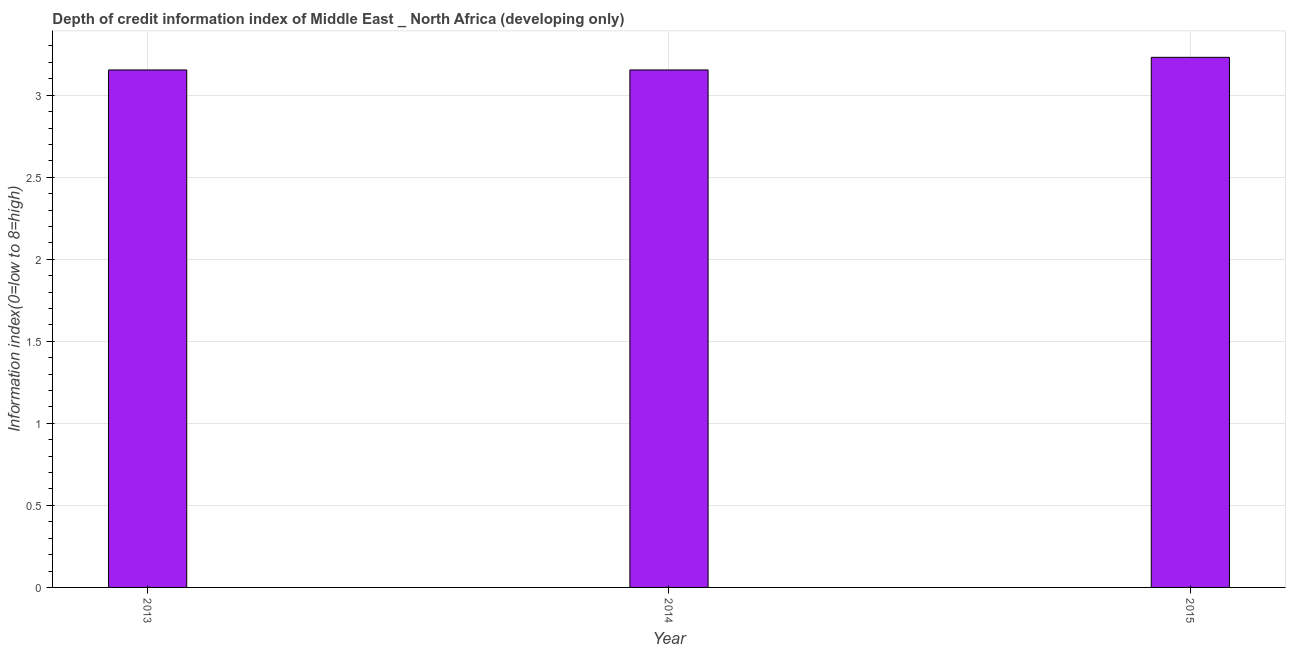Does the graph contain any zero values?
Your answer should be very brief. No. What is the title of the graph?
Provide a short and direct response. Depth of credit information index of Middle East _ North Africa (developing only). What is the label or title of the Y-axis?
Offer a very short reply. Information index(0=low to 8=high). What is the depth of credit information index in 2014?
Offer a terse response. 3.15. Across all years, what is the maximum depth of credit information index?
Make the answer very short. 3.23. Across all years, what is the minimum depth of credit information index?
Offer a very short reply. 3.15. In which year was the depth of credit information index maximum?
Ensure brevity in your answer.  2015. What is the sum of the depth of credit information index?
Provide a succinct answer. 9.54. What is the difference between the depth of credit information index in 2014 and 2015?
Provide a short and direct response. -0.08. What is the average depth of credit information index per year?
Your answer should be very brief. 3.18. What is the median depth of credit information index?
Your answer should be very brief. 3.15. What is the ratio of the depth of credit information index in 2014 to that in 2015?
Your answer should be very brief. 0.98. Is the depth of credit information index in 2013 less than that in 2014?
Your answer should be compact. No. Is the difference between the depth of credit information index in 2013 and 2014 greater than the difference between any two years?
Make the answer very short. No. What is the difference between the highest and the second highest depth of credit information index?
Offer a very short reply. 0.08. What is the difference between the highest and the lowest depth of credit information index?
Give a very brief answer. 0.08. In how many years, is the depth of credit information index greater than the average depth of credit information index taken over all years?
Offer a very short reply. 1. Are all the bars in the graph horizontal?
Your answer should be compact. No. How many years are there in the graph?
Keep it short and to the point. 3. Are the values on the major ticks of Y-axis written in scientific E-notation?
Your answer should be very brief. No. What is the Information index(0=low to 8=high) in 2013?
Offer a very short reply. 3.15. What is the Information index(0=low to 8=high) of 2014?
Your response must be concise. 3.15. What is the Information index(0=low to 8=high) of 2015?
Your response must be concise. 3.23. What is the difference between the Information index(0=low to 8=high) in 2013 and 2015?
Offer a very short reply. -0.08. What is the difference between the Information index(0=low to 8=high) in 2014 and 2015?
Your response must be concise. -0.08. What is the ratio of the Information index(0=low to 8=high) in 2013 to that in 2014?
Offer a very short reply. 1. What is the ratio of the Information index(0=low to 8=high) in 2013 to that in 2015?
Your answer should be compact. 0.98. 